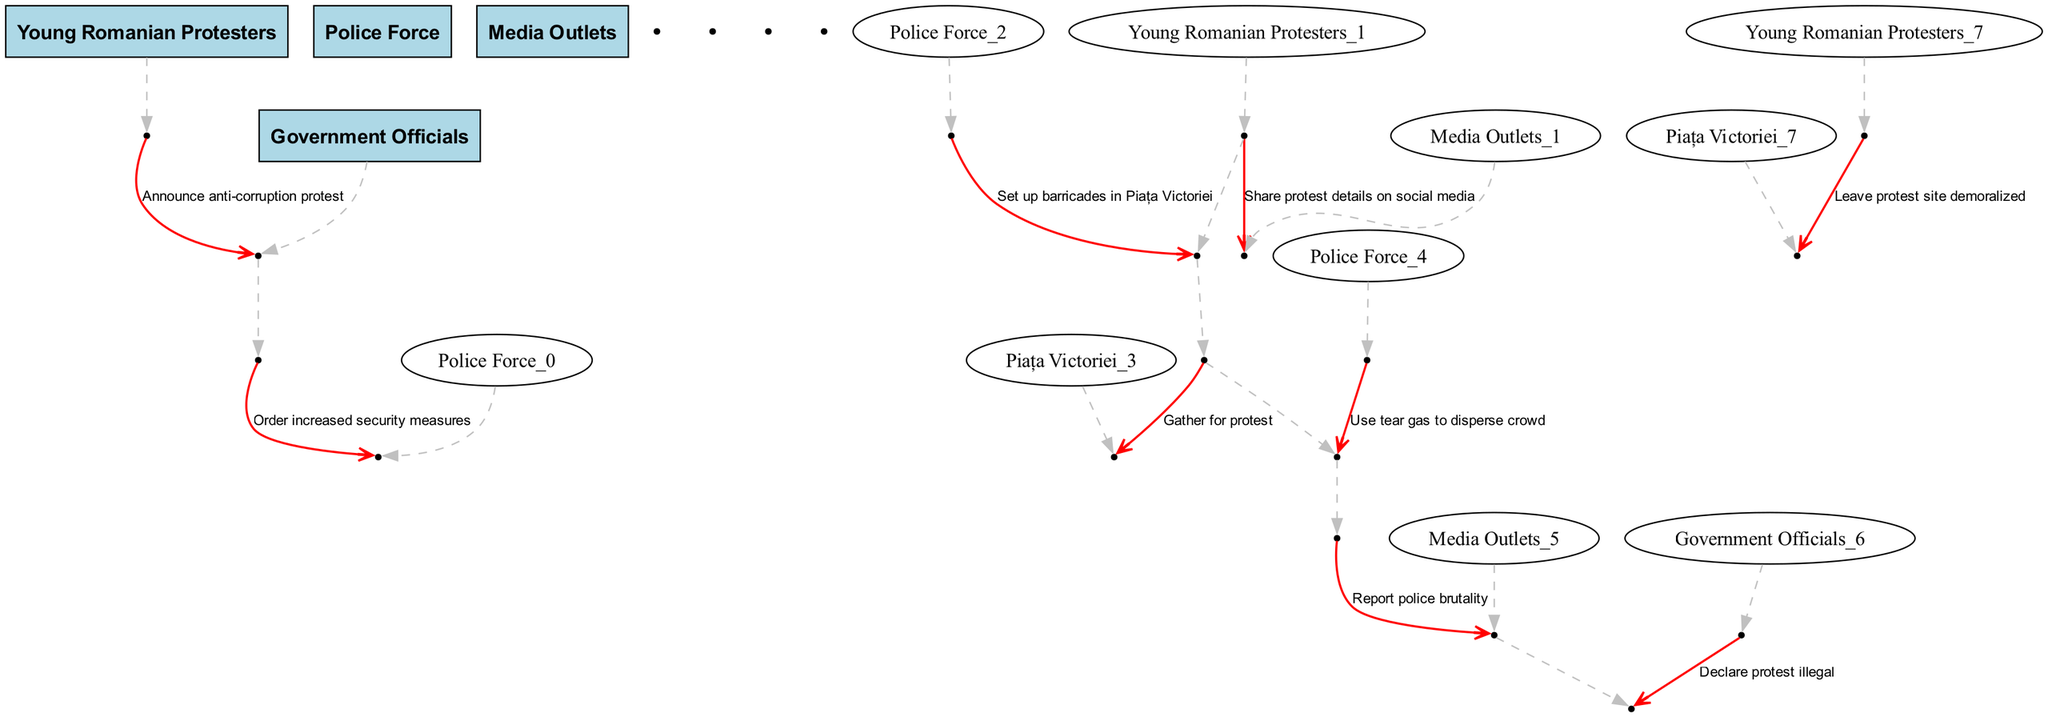What is the first action taken by young Romanian protesters? The first action is to announce the anti-corruption protest to the government officials. This can be determined by looking at the first event in the sequence.
Answer: Announce anti-corruption protest How many times do young Romanian protesters interact with media outlets? The young Romanian protesters interact with media outlets two times in the sequence. This is determined by counting the events where they send messages to the media outlets.
Answer: 2 What security measure was ordered by government officials? The government officials ordered increased security measures to the police force. This can be seen in the second event where the message flows from government officials to the police.
Answer: Order increased security measures What action did the police force take after the crowd gathered? The police force used tear gas to disperse the crowd after the young Romanian protesters gathered for the protest. This is evident in the fifth and sixth events that show the progression of actions.
Answer: Use tear gas to disperse crowd How do young Romanian protesters feel at the end of the protest? The young Romanian protesters leave the protest site demoralized. This is shown in the last event where they interact with Piața Victoriei after the protest.
Answer: Leave protest site demoralized What was the government officials' declaration regarding the protest? The government officials declared the protest illegal as indicated in the eighth event where they communicate with media outlets.
Answer: Declare protest illegal What did young Romanian protesters report to media outlets following the protest? The young Romanian protesters reported police brutality to the media outlets after experiencing violence from the police, which is described in the seventh event.
Answer: Report police brutality What was set up by police in response to the protest announcement? Barricades were set up by police in Piața Victoriei after the announcement of the protest by young Romanian protesters. This is indicated in the fourth event showing the action taken by police.
Answer: Set up barricades in Piața Victoriei 